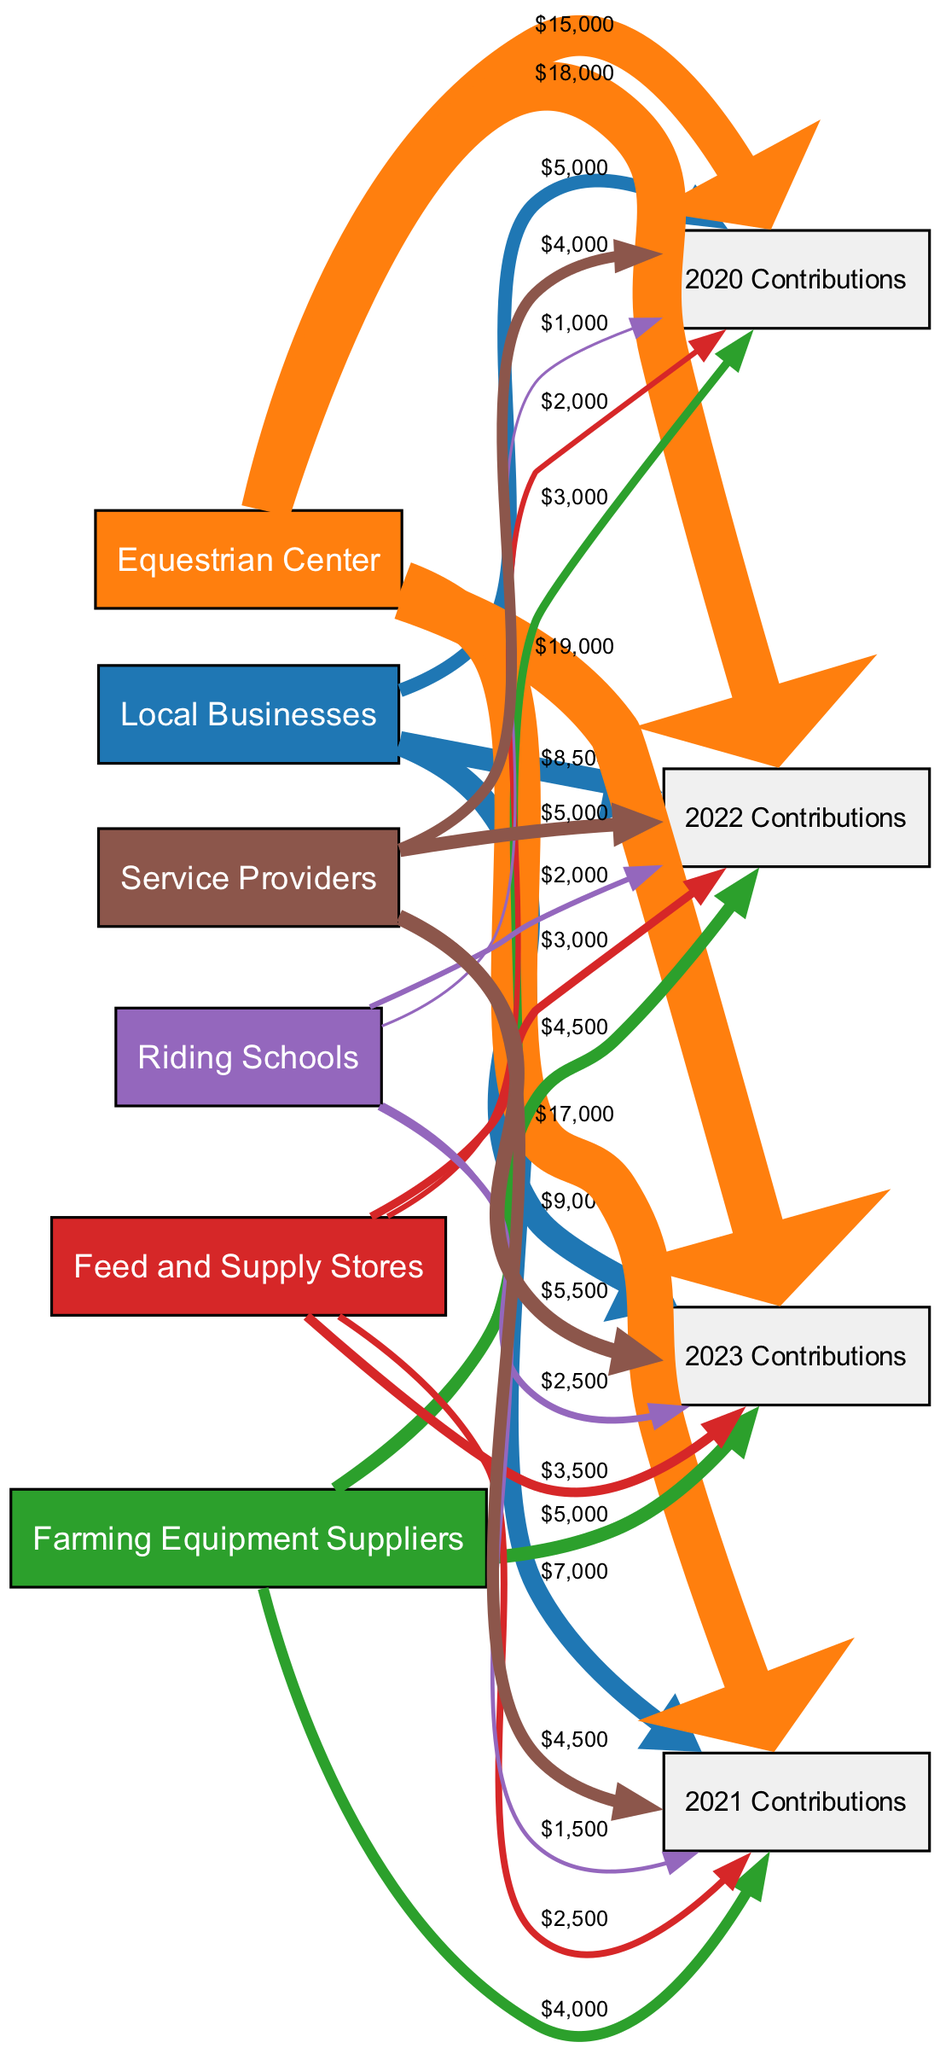What is the total contribution from Local Businesses in 2023? The link from "Local Businesses" to "2023 Contributions" shows a value of 9000. Thus, the total contribution is simply the value represented in that link.
Answer: 9000 Which business type had the highest contributions in 2022? By comparing the values linked from all business types to "2022 Contributions", the highest value is from "Equestrian Center" with a contribution of 18000. Hence, it had the highest contributions in that year.
Answer: Equestrian Center What is the total contribution from Feed and Supply Stores from 2020 to 2023? To find this, we sum the contributions for each year from "Feed and Supply Stores": 2000 (2020) + 2500 (2021) + 3000 (2022) + 3500 (2023) = 11000. This total gives the overall contribution from this business type over the four years.
Answer: 11000 How much did Service Providers contribute in 2021? The contribution from "Service Providers" to "2021 Contributions" is 4500. This value is directly indicated in the link for that year.
Answer: 4500 Which business type saw the largest increase in contributions from 2020 to 2023? To find this, we calculate the difference between the contributions in 2023 and 2020 for each business type. The largest increase is for the "Equestrian Center" with an increase of 4000 (19000 - 15000). Thus, this business type experienced the most substantial growth over that period.
Answer: Equestrian Center What was the total contribution for all business types in 2020? We need to sum the contributions from all business types for that year: 5000 (Local Businesses) + 15000 (Equestrian Center) + 3000 (Farming Equipment Suppliers) + 2000 (Feed and Supply Stores) + 1000 (Riding Schools) + 4000 (Service Providers) = 25000. This total represents the complete contributions for 2020.
Answer: 25000 How many nodes are represented in the diagram? The diagram contains a total of 10 nodes, as counted in the data provided, representing various business types and their contributions over the years.
Answer: 10 What is the total flow of contributions from Farming Equipment Suppliers in 2023 compared to 2020? The contribution from "Farming Equipment Suppliers" in 2023 is 5000, while in 2020 it was 3000. To find the total flow, note the value in 2023 and 2020, which helps indicate the change in support over time.
Answer: 5000 What type of diagram is being used to represent this data? The diagram type is a Sankey Diagram, which visually represents the flow of contributions from various sources to their respective outcomes over the years.
Answer: Sankey Diagram 